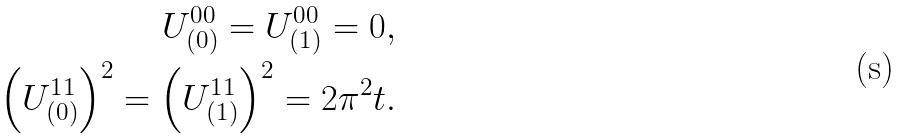<formula> <loc_0><loc_0><loc_500><loc_500>U _ { ( 0 ) } ^ { 0 0 } = U _ { ( 1 ) } ^ { 0 0 } = 0 , \\ \left ( U _ { ( 0 ) } ^ { 1 1 } \right ) ^ { 2 } = \left ( U _ { ( 1 ) } ^ { 1 1 } \right ) ^ { 2 } = 2 \pi ^ { 2 } t .</formula> 